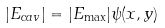<formula> <loc_0><loc_0><loc_500><loc_500>| E _ { c a v } | = | E _ { \max } | \psi ( x , y )</formula> 